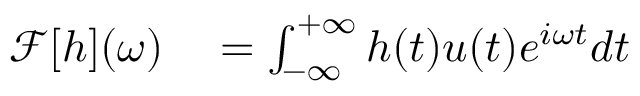<formula> <loc_0><loc_0><loc_500><loc_500>\begin{array} { r } { \begin{array} { r l } { \mathcal { F } [ h ] ( \omega ) } & = \int _ { - \infty } ^ { + \infty } h ( t ) u ( t ) e ^ { i \omega t } d t } \end{array} } \end{array}</formula> 